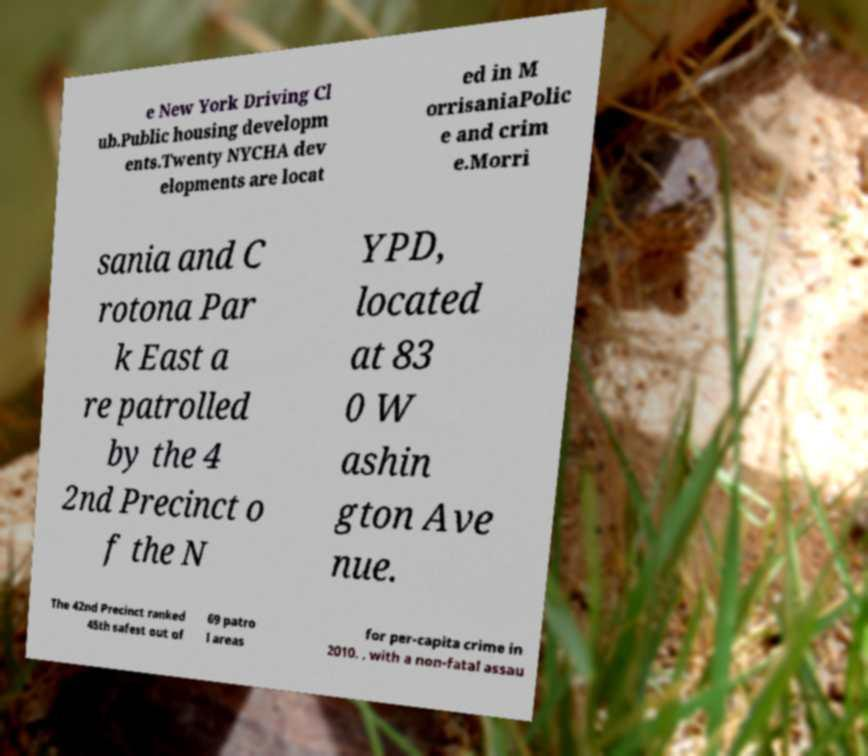There's text embedded in this image that I need extracted. Can you transcribe it verbatim? e New York Driving Cl ub.Public housing developm ents.Twenty NYCHA dev elopments are locat ed in M orrisaniaPolic e and crim e.Morri sania and C rotona Par k East a re patrolled by the 4 2nd Precinct o f the N YPD, located at 83 0 W ashin gton Ave nue. The 42nd Precinct ranked 45th safest out of 69 patro l areas for per-capita crime in 2010. , with a non-fatal assau 